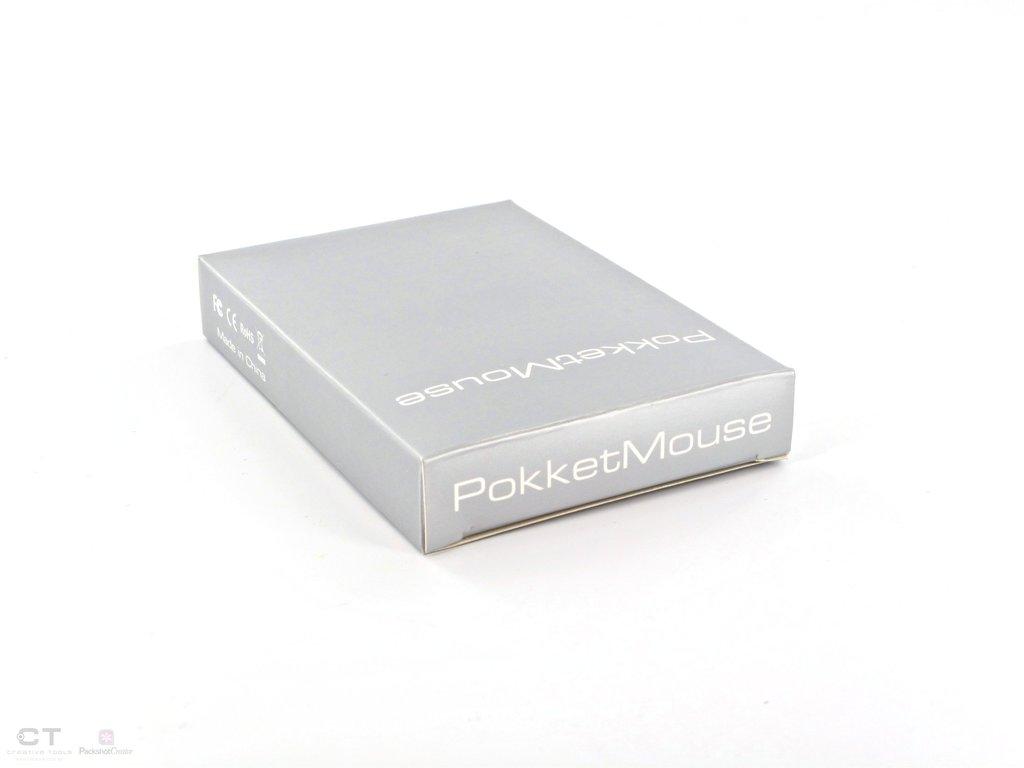What kind of mouse is this?
Your answer should be compact. Pokketmouse. What two letters are in the bottom left corner?
Your answer should be very brief. Ct. 